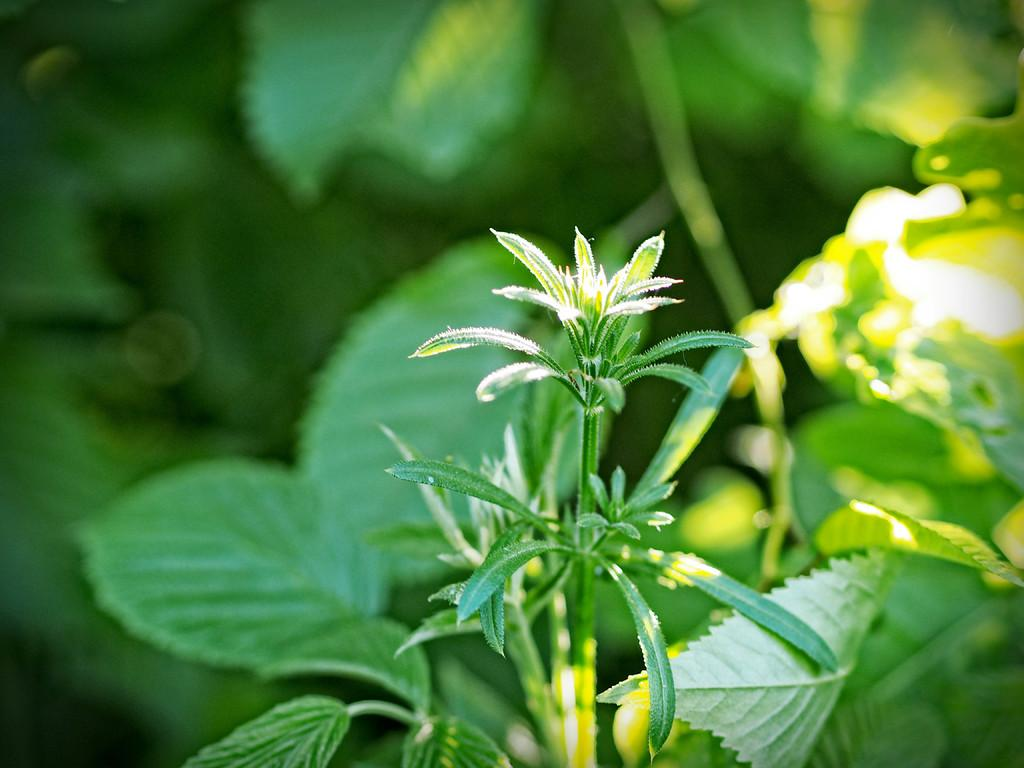What type of living organisms can be seen in the image? Plants can be seen in the image. Can you describe the background of the image? The background of the image is blurred. What type of mass can be seen moving across the sidewalk in the image? There is no sidewalk or mass visible in the image; it only features plants and a blurred background. 